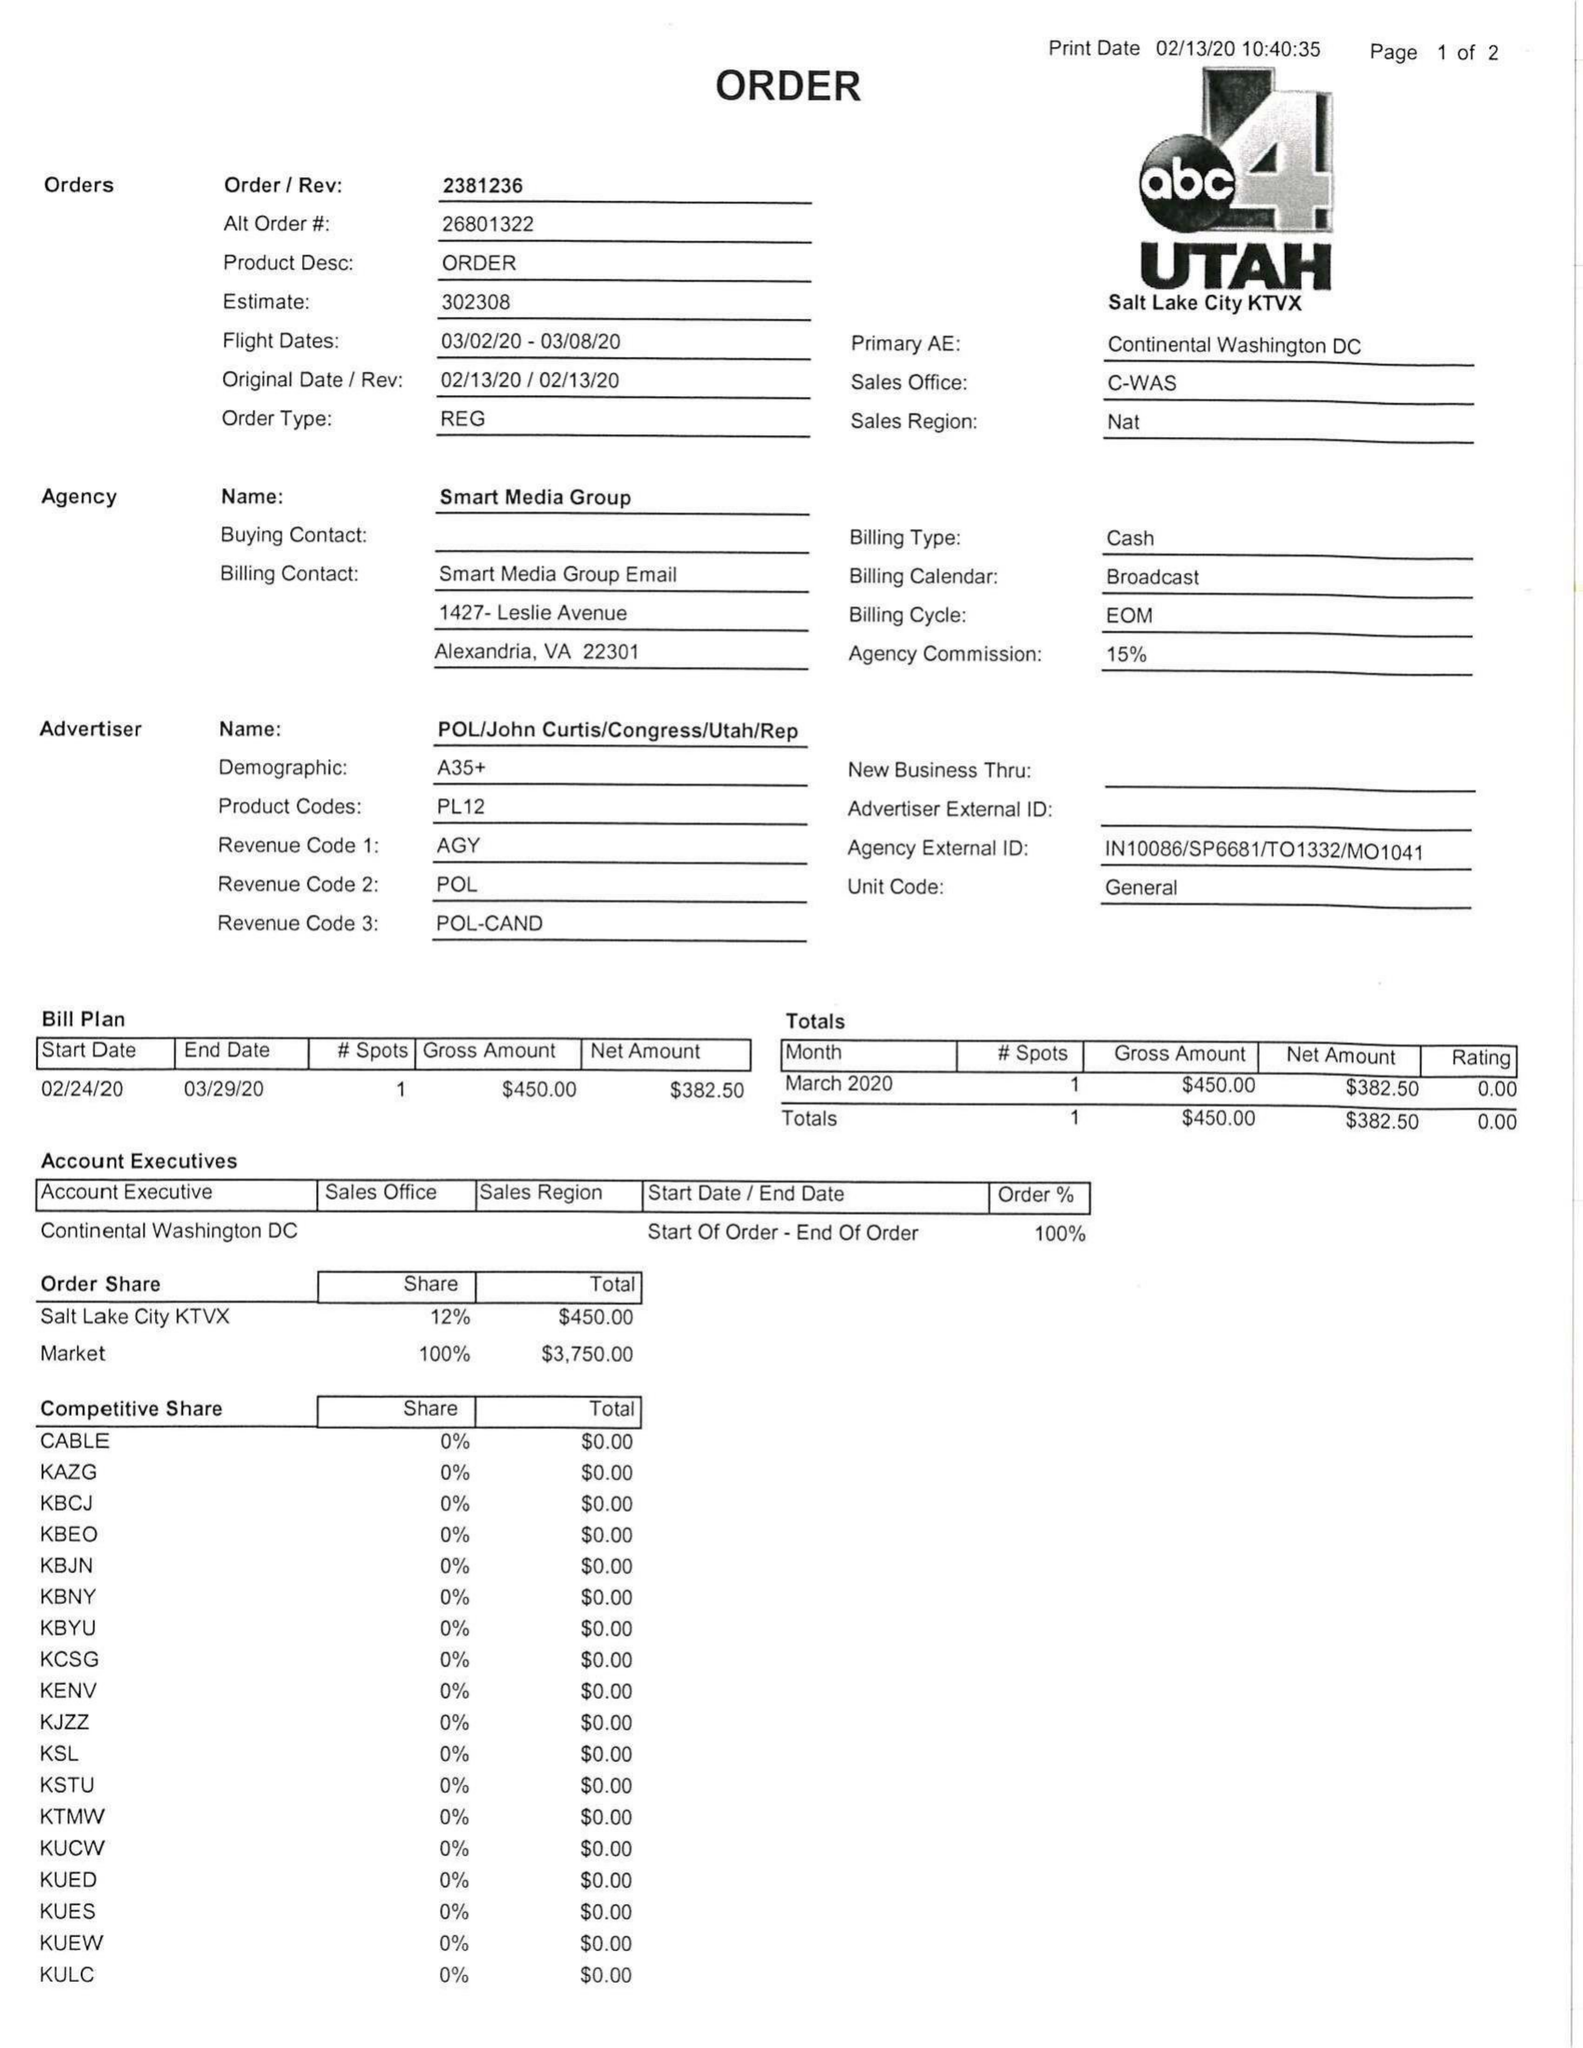What is the value for the flight_from?
Answer the question using a single word or phrase. 03/02/20 